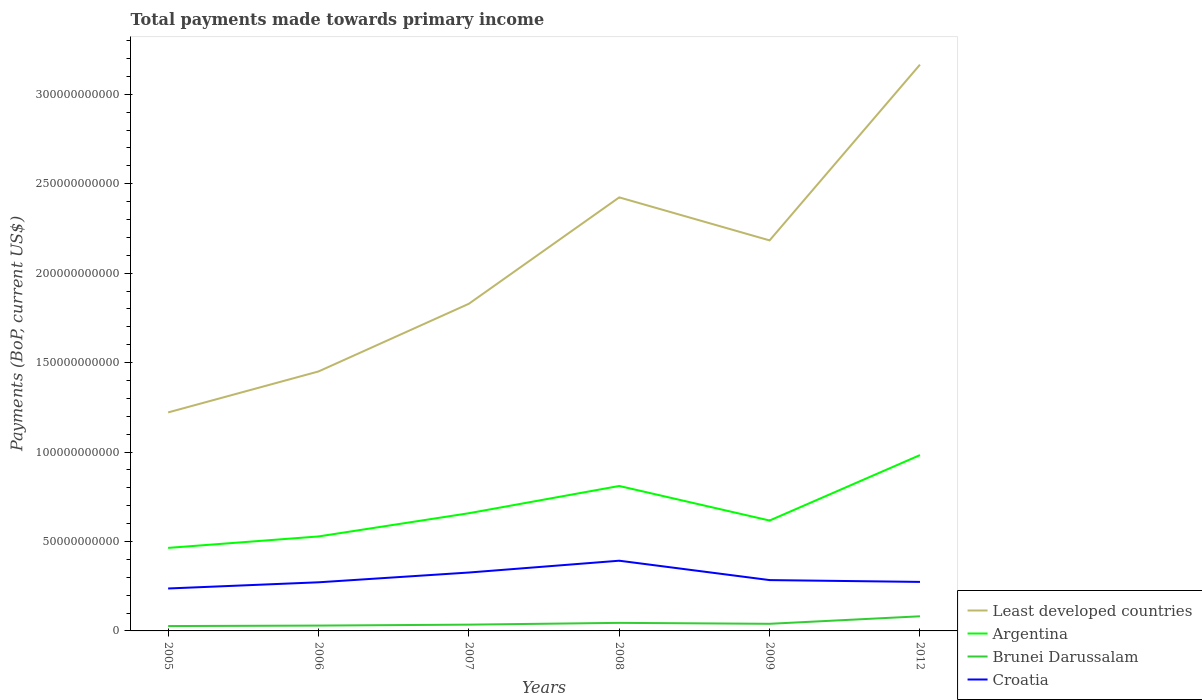Does the line corresponding to Brunei Darussalam intersect with the line corresponding to Argentina?
Your answer should be compact. No. Is the number of lines equal to the number of legend labels?
Offer a terse response. Yes. Across all years, what is the maximum total payments made towards primary income in Brunei Darussalam?
Your response must be concise. 2.71e+09. In which year was the total payments made towards primary income in Argentina maximum?
Give a very brief answer. 2005. What is the total total payments made towards primary income in Least developed countries in the graph?
Your response must be concise. -6.07e+1. What is the difference between the highest and the second highest total payments made towards primary income in Least developed countries?
Give a very brief answer. 1.94e+11. Is the total payments made towards primary income in Argentina strictly greater than the total payments made towards primary income in Croatia over the years?
Your answer should be compact. No. How many years are there in the graph?
Your response must be concise. 6. What is the difference between two consecutive major ticks on the Y-axis?
Keep it short and to the point. 5.00e+1. Are the values on the major ticks of Y-axis written in scientific E-notation?
Your answer should be very brief. No. How are the legend labels stacked?
Your answer should be very brief. Vertical. What is the title of the graph?
Give a very brief answer. Total payments made towards primary income. Does "Kenya" appear as one of the legend labels in the graph?
Provide a short and direct response. No. What is the label or title of the X-axis?
Make the answer very short. Years. What is the label or title of the Y-axis?
Offer a very short reply. Payments (BoP, current US$). What is the Payments (BoP, current US$) of Least developed countries in 2005?
Offer a terse response. 1.22e+11. What is the Payments (BoP, current US$) in Argentina in 2005?
Offer a very short reply. 4.64e+1. What is the Payments (BoP, current US$) of Brunei Darussalam in 2005?
Your answer should be compact. 2.71e+09. What is the Payments (BoP, current US$) of Croatia in 2005?
Provide a succinct answer. 2.37e+1. What is the Payments (BoP, current US$) of Least developed countries in 2006?
Offer a very short reply. 1.45e+11. What is the Payments (BoP, current US$) of Argentina in 2006?
Ensure brevity in your answer.  5.28e+1. What is the Payments (BoP, current US$) of Brunei Darussalam in 2006?
Give a very brief answer. 2.98e+09. What is the Payments (BoP, current US$) in Croatia in 2006?
Give a very brief answer. 2.72e+1. What is the Payments (BoP, current US$) in Least developed countries in 2007?
Ensure brevity in your answer.  1.83e+11. What is the Payments (BoP, current US$) of Argentina in 2007?
Your response must be concise. 6.58e+1. What is the Payments (BoP, current US$) of Brunei Darussalam in 2007?
Your answer should be compact. 3.51e+09. What is the Payments (BoP, current US$) of Croatia in 2007?
Make the answer very short. 3.26e+1. What is the Payments (BoP, current US$) of Least developed countries in 2008?
Provide a succinct answer. 2.42e+11. What is the Payments (BoP, current US$) of Argentina in 2008?
Provide a succinct answer. 8.10e+1. What is the Payments (BoP, current US$) of Brunei Darussalam in 2008?
Give a very brief answer. 4.51e+09. What is the Payments (BoP, current US$) of Croatia in 2008?
Give a very brief answer. 3.92e+1. What is the Payments (BoP, current US$) of Least developed countries in 2009?
Offer a terse response. 2.18e+11. What is the Payments (BoP, current US$) in Argentina in 2009?
Provide a short and direct response. 6.17e+1. What is the Payments (BoP, current US$) in Brunei Darussalam in 2009?
Offer a very short reply. 3.98e+09. What is the Payments (BoP, current US$) of Croatia in 2009?
Offer a very short reply. 2.84e+1. What is the Payments (BoP, current US$) of Least developed countries in 2012?
Your answer should be very brief. 3.17e+11. What is the Payments (BoP, current US$) in Argentina in 2012?
Keep it short and to the point. 9.83e+1. What is the Payments (BoP, current US$) in Brunei Darussalam in 2012?
Offer a very short reply. 8.18e+09. What is the Payments (BoP, current US$) in Croatia in 2012?
Make the answer very short. 2.74e+1. Across all years, what is the maximum Payments (BoP, current US$) of Least developed countries?
Offer a terse response. 3.17e+11. Across all years, what is the maximum Payments (BoP, current US$) in Argentina?
Offer a very short reply. 9.83e+1. Across all years, what is the maximum Payments (BoP, current US$) of Brunei Darussalam?
Offer a terse response. 8.18e+09. Across all years, what is the maximum Payments (BoP, current US$) of Croatia?
Your answer should be compact. 3.92e+1. Across all years, what is the minimum Payments (BoP, current US$) in Least developed countries?
Provide a short and direct response. 1.22e+11. Across all years, what is the minimum Payments (BoP, current US$) of Argentina?
Give a very brief answer. 4.64e+1. Across all years, what is the minimum Payments (BoP, current US$) of Brunei Darussalam?
Keep it short and to the point. 2.71e+09. Across all years, what is the minimum Payments (BoP, current US$) in Croatia?
Offer a terse response. 2.37e+1. What is the total Payments (BoP, current US$) of Least developed countries in the graph?
Give a very brief answer. 1.23e+12. What is the total Payments (BoP, current US$) in Argentina in the graph?
Ensure brevity in your answer.  4.06e+11. What is the total Payments (BoP, current US$) in Brunei Darussalam in the graph?
Your answer should be compact. 2.59e+1. What is the total Payments (BoP, current US$) in Croatia in the graph?
Keep it short and to the point. 1.79e+11. What is the difference between the Payments (BoP, current US$) of Least developed countries in 2005 and that in 2006?
Keep it short and to the point. -2.29e+1. What is the difference between the Payments (BoP, current US$) of Argentina in 2005 and that in 2006?
Provide a succinct answer. -6.39e+09. What is the difference between the Payments (BoP, current US$) in Brunei Darussalam in 2005 and that in 2006?
Offer a terse response. -2.72e+08. What is the difference between the Payments (BoP, current US$) in Croatia in 2005 and that in 2006?
Ensure brevity in your answer.  -3.46e+09. What is the difference between the Payments (BoP, current US$) of Least developed countries in 2005 and that in 2007?
Your response must be concise. -6.07e+1. What is the difference between the Payments (BoP, current US$) in Argentina in 2005 and that in 2007?
Your answer should be compact. -1.94e+1. What is the difference between the Payments (BoP, current US$) of Brunei Darussalam in 2005 and that in 2007?
Give a very brief answer. -8.03e+08. What is the difference between the Payments (BoP, current US$) in Croatia in 2005 and that in 2007?
Give a very brief answer. -8.92e+09. What is the difference between the Payments (BoP, current US$) of Least developed countries in 2005 and that in 2008?
Give a very brief answer. -1.20e+11. What is the difference between the Payments (BoP, current US$) in Argentina in 2005 and that in 2008?
Your answer should be very brief. -3.46e+1. What is the difference between the Payments (BoP, current US$) in Brunei Darussalam in 2005 and that in 2008?
Keep it short and to the point. -1.80e+09. What is the difference between the Payments (BoP, current US$) of Croatia in 2005 and that in 2008?
Your response must be concise. -1.55e+1. What is the difference between the Payments (BoP, current US$) in Least developed countries in 2005 and that in 2009?
Provide a succinct answer. -9.62e+1. What is the difference between the Payments (BoP, current US$) in Argentina in 2005 and that in 2009?
Offer a terse response. -1.53e+1. What is the difference between the Payments (BoP, current US$) of Brunei Darussalam in 2005 and that in 2009?
Ensure brevity in your answer.  -1.27e+09. What is the difference between the Payments (BoP, current US$) of Croatia in 2005 and that in 2009?
Your answer should be very brief. -4.69e+09. What is the difference between the Payments (BoP, current US$) in Least developed countries in 2005 and that in 2012?
Your answer should be compact. -1.94e+11. What is the difference between the Payments (BoP, current US$) of Argentina in 2005 and that in 2012?
Provide a succinct answer. -5.19e+1. What is the difference between the Payments (BoP, current US$) of Brunei Darussalam in 2005 and that in 2012?
Your answer should be compact. -5.47e+09. What is the difference between the Payments (BoP, current US$) of Croatia in 2005 and that in 2012?
Ensure brevity in your answer.  -3.68e+09. What is the difference between the Payments (BoP, current US$) in Least developed countries in 2006 and that in 2007?
Give a very brief answer. -3.78e+1. What is the difference between the Payments (BoP, current US$) in Argentina in 2006 and that in 2007?
Offer a very short reply. -1.30e+1. What is the difference between the Payments (BoP, current US$) in Brunei Darussalam in 2006 and that in 2007?
Offer a very short reply. -5.30e+08. What is the difference between the Payments (BoP, current US$) in Croatia in 2006 and that in 2007?
Ensure brevity in your answer.  -5.47e+09. What is the difference between the Payments (BoP, current US$) of Least developed countries in 2006 and that in 2008?
Your answer should be very brief. -9.73e+1. What is the difference between the Payments (BoP, current US$) in Argentina in 2006 and that in 2008?
Give a very brief answer. -2.82e+1. What is the difference between the Payments (BoP, current US$) of Brunei Darussalam in 2006 and that in 2008?
Offer a very short reply. -1.52e+09. What is the difference between the Payments (BoP, current US$) of Croatia in 2006 and that in 2008?
Keep it short and to the point. -1.21e+1. What is the difference between the Payments (BoP, current US$) in Least developed countries in 2006 and that in 2009?
Offer a very short reply. -7.33e+1. What is the difference between the Payments (BoP, current US$) of Argentina in 2006 and that in 2009?
Keep it short and to the point. -8.90e+09. What is the difference between the Payments (BoP, current US$) of Brunei Darussalam in 2006 and that in 2009?
Your answer should be compact. -9.96e+08. What is the difference between the Payments (BoP, current US$) of Croatia in 2006 and that in 2009?
Provide a short and direct response. -1.24e+09. What is the difference between the Payments (BoP, current US$) of Least developed countries in 2006 and that in 2012?
Your answer should be very brief. -1.72e+11. What is the difference between the Payments (BoP, current US$) in Argentina in 2006 and that in 2012?
Give a very brief answer. -4.55e+1. What is the difference between the Payments (BoP, current US$) of Brunei Darussalam in 2006 and that in 2012?
Give a very brief answer. -5.20e+09. What is the difference between the Payments (BoP, current US$) of Croatia in 2006 and that in 2012?
Your answer should be very brief. -2.25e+08. What is the difference between the Payments (BoP, current US$) of Least developed countries in 2007 and that in 2008?
Your answer should be compact. -5.95e+1. What is the difference between the Payments (BoP, current US$) of Argentina in 2007 and that in 2008?
Make the answer very short. -1.52e+1. What is the difference between the Payments (BoP, current US$) of Brunei Darussalam in 2007 and that in 2008?
Give a very brief answer. -9.95e+08. What is the difference between the Payments (BoP, current US$) in Croatia in 2007 and that in 2008?
Offer a terse response. -6.60e+09. What is the difference between the Payments (BoP, current US$) of Least developed countries in 2007 and that in 2009?
Offer a very short reply. -3.54e+1. What is the difference between the Payments (BoP, current US$) in Argentina in 2007 and that in 2009?
Ensure brevity in your answer.  4.09e+09. What is the difference between the Payments (BoP, current US$) of Brunei Darussalam in 2007 and that in 2009?
Your answer should be very brief. -4.66e+08. What is the difference between the Payments (BoP, current US$) in Croatia in 2007 and that in 2009?
Your response must be concise. 4.23e+09. What is the difference between the Payments (BoP, current US$) in Least developed countries in 2007 and that in 2012?
Offer a terse response. -1.34e+11. What is the difference between the Payments (BoP, current US$) of Argentina in 2007 and that in 2012?
Make the answer very short. -3.25e+1. What is the difference between the Payments (BoP, current US$) in Brunei Darussalam in 2007 and that in 2012?
Keep it short and to the point. -4.67e+09. What is the difference between the Payments (BoP, current US$) of Croatia in 2007 and that in 2012?
Your answer should be compact. 5.24e+09. What is the difference between the Payments (BoP, current US$) in Least developed countries in 2008 and that in 2009?
Provide a succinct answer. 2.40e+1. What is the difference between the Payments (BoP, current US$) of Argentina in 2008 and that in 2009?
Your answer should be compact. 1.93e+1. What is the difference between the Payments (BoP, current US$) of Brunei Darussalam in 2008 and that in 2009?
Keep it short and to the point. 5.28e+08. What is the difference between the Payments (BoP, current US$) of Croatia in 2008 and that in 2009?
Give a very brief answer. 1.08e+1. What is the difference between the Payments (BoP, current US$) of Least developed countries in 2008 and that in 2012?
Ensure brevity in your answer.  -7.42e+1. What is the difference between the Payments (BoP, current US$) of Argentina in 2008 and that in 2012?
Your response must be concise. -1.73e+1. What is the difference between the Payments (BoP, current US$) of Brunei Darussalam in 2008 and that in 2012?
Provide a succinct answer. -3.67e+09. What is the difference between the Payments (BoP, current US$) of Croatia in 2008 and that in 2012?
Your response must be concise. 1.18e+1. What is the difference between the Payments (BoP, current US$) of Least developed countries in 2009 and that in 2012?
Offer a terse response. -9.82e+1. What is the difference between the Payments (BoP, current US$) in Argentina in 2009 and that in 2012?
Offer a very short reply. -3.66e+1. What is the difference between the Payments (BoP, current US$) in Brunei Darussalam in 2009 and that in 2012?
Provide a succinct answer. -4.20e+09. What is the difference between the Payments (BoP, current US$) of Croatia in 2009 and that in 2012?
Provide a succinct answer. 1.01e+09. What is the difference between the Payments (BoP, current US$) in Least developed countries in 2005 and the Payments (BoP, current US$) in Argentina in 2006?
Offer a very short reply. 6.93e+1. What is the difference between the Payments (BoP, current US$) in Least developed countries in 2005 and the Payments (BoP, current US$) in Brunei Darussalam in 2006?
Offer a terse response. 1.19e+11. What is the difference between the Payments (BoP, current US$) in Least developed countries in 2005 and the Payments (BoP, current US$) in Croatia in 2006?
Give a very brief answer. 9.50e+1. What is the difference between the Payments (BoP, current US$) in Argentina in 2005 and the Payments (BoP, current US$) in Brunei Darussalam in 2006?
Your answer should be very brief. 4.34e+1. What is the difference between the Payments (BoP, current US$) of Argentina in 2005 and the Payments (BoP, current US$) of Croatia in 2006?
Ensure brevity in your answer.  1.92e+1. What is the difference between the Payments (BoP, current US$) of Brunei Darussalam in 2005 and the Payments (BoP, current US$) of Croatia in 2006?
Your answer should be compact. -2.45e+1. What is the difference between the Payments (BoP, current US$) in Least developed countries in 2005 and the Payments (BoP, current US$) in Argentina in 2007?
Make the answer very short. 5.63e+1. What is the difference between the Payments (BoP, current US$) in Least developed countries in 2005 and the Payments (BoP, current US$) in Brunei Darussalam in 2007?
Offer a terse response. 1.19e+11. What is the difference between the Payments (BoP, current US$) of Least developed countries in 2005 and the Payments (BoP, current US$) of Croatia in 2007?
Your response must be concise. 8.95e+1. What is the difference between the Payments (BoP, current US$) of Argentina in 2005 and the Payments (BoP, current US$) of Brunei Darussalam in 2007?
Your response must be concise. 4.29e+1. What is the difference between the Payments (BoP, current US$) in Argentina in 2005 and the Payments (BoP, current US$) in Croatia in 2007?
Ensure brevity in your answer.  1.38e+1. What is the difference between the Payments (BoP, current US$) in Brunei Darussalam in 2005 and the Payments (BoP, current US$) in Croatia in 2007?
Keep it short and to the point. -2.99e+1. What is the difference between the Payments (BoP, current US$) in Least developed countries in 2005 and the Payments (BoP, current US$) in Argentina in 2008?
Provide a short and direct response. 4.11e+1. What is the difference between the Payments (BoP, current US$) of Least developed countries in 2005 and the Payments (BoP, current US$) of Brunei Darussalam in 2008?
Make the answer very short. 1.18e+11. What is the difference between the Payments (BoP, current US$) of Least developed countries in 2005 and the Payments (BoP, current US$) of Croatia in 2008?
Your answer should be compact. 8.29e+1. What is the difference between the Payments (BoP, current US$) in Argentina in 2005 and the Payments (BoP, current US$) in Brunei Darussalam in 2008?
Provide a short and direct response. 4.19e+1. What is the difference between the Payments (BoP, current US$) in Argentina in 2005 and the Payments (BoP, current US$) in Croatia in 2008?
Provide a succinct answer. 7.17e+09. What is the difference between the Payments (BoP, current US$) in Brunei Darussalam in 2005 and the Payments (BoP, current US$) in Croatia in 2008?
Keep it short and to the point. -3.65e+1. What is the difference between the Payments (BoP, current US$) of Least developed countries in 2005 and the Payments (BoP, current US$) of Argentina in 2009?
Provide a succinct answer. 6.04e+1. What is the difference between the Payments (BoP, current US$) in Least developed countries in 2005 and the Payments (BoP, current US$) in Brunei Darussalam in 2009?
Offer a terse response. 1.18e+11. What is the difference between the Payments (BoP, current US$) in Least developed countries in 2005 and the Payments (BoP, current US$) in Croatia in 2009?
Your response must be concise. 9.37e+1. What is the difference between the Payments (BoP, current US$) in Argentina in 2005 and the Payments (BoP, current US$) in Brunei Darussalam in 2009?
Keep it short and to the point. 4.24e+1. What is the difference between the Payments (BoP, current US$) of Argentina in 2005 and the Payments (BoP, current US$) of Croatia in 2009?
Provide a succinct answer. 1.80e+1. What is the difference between the Payments (BoP, current US$) in Brunei Darussalam in 2005 and the Payments (BoP, current US$) in Croatia in 2009?
Your answer should be compact. -2.57e+1. What is the difference between the Payments (BoP, current US$) of Least developed countries in 2005 and the Payments (BoP, current US$) of Argentina in 2012?
Your response must be concise. 2.39e+1. What is the difference between the Payments (BoP, current US$) in Least developed countries in 2005 and the Payments (BoP, current US$) in Brunei Darussalam in 2012?
Your answer should be compact. 1.14e+11. What is the difference between the Payments (BoP, current US$) of Least developed countries in 2005 and the Payments (BoP, current US$) of Croatia in 2012?
Keep it short and to the point. 9.47e+1. What is the difference between the Payments (BoP, current US$) of Argentina in 2005 and the Payments (BoP, current US$) of Brunei Darussalam in 2012?
Offer a terse response. 3.82e+1. What is the difference between the Payments (BoP, current US$) of Argentina in 2005 and the Payments (BoP, current US$) of Croatia in 2012?
Give a very brief answer. 1.90e+1. What is the difference between the Payments (BoP, current US$) in Brunei Darussalam in 2005 and the Payments (BoP, current US$) in Croatia in 2012?
Make the answer very short. -2.47e+1. What is the difference between the Payments (BoP, current US$) in Least developed countries in 2006 and the Payments (BoP, current US$) in Argentina in 2007?
Provide a succinct answer. 7.92e+1. What is the difference between the Payments (BoP, current US$) in Least developed countries in 2006 and the Payments (BoP, current US$) in Brunei Darussalam in 2007?
Keep it short and to the point. 1.42e+11. What is the difference between the Payments (BoP, current US$) of Least developed countries in 2006 and the Payments (BoP, current US$) of Croatia in 2007?
Your answer should be compact. 1.12e+11. What is the difference between the Payments (BoP, current US$) in Argentina in 2006 and the Payments (BoP, current US$) in Brunei Darussalam in 2007?
Provide a succinct answer. 4.93e+1. What is the difference between the Payments (BoP, current US$) of Argentina in 2006 and the Payments (BoP, current US$) of Croatia in 2007?
Offer a very short reply. 2.02e+1. What is the difference between the Payments (BoP, current US$) in Brunei Darussalam in 2006 and the Payments (BoP, current US$) in Croatia in 2007?
Make the answer very short. -2.97e+1. What is the difference between the Payments (BoP, current US$) in Least developed countries in 2006 and the Payments (BoP, current US$) in Argentina in 2008?
Provide a short and direct response. 6.40e+1. What is the difference between the Payments (BoP, current US$) in Least developed countries in 2006 and the Payments (BoP, current US$) in Brunei Darussalam in 2008?
Keep it short and to the point. 1.41e+11. What is the difference between the Payments (BoP, current US$) of Least developed countries in 2006 and the Payments (BoP, current US$) of Croatia in 2008?
Offer a terse response. 1.06e+11. What is the difference between the Payments (BoP, current US$) of Argentina in 2006 and the Payments (BoP, current US$) of Brunei Darussalam in 2008?
Make the answer very short. 4.83e+1. What is the difference between the Payments (BoP, current US$) of Argentina in 2006 and the Payments (BoP, current US$) of Croatia in 2008?
Ensure brevity in your answer.  1.36e+1. What is the difference between the Payments (BoP, current US$) in Brunei Darussalam in 2006 and the Payments (BoP, current US$) in Croatia in 2008?
Give a very brief answer. -3.63e+1. What is the difference between the Payments (BoP, current US$) in Least developed countries in 2006 and the Payments (BoP, current US$) in Argentina in 2009?
Provide a succinct answer. 8.33e+1. What is the difference between the Payments (BoP, current US$) of Least developed countries in 2006 and the Payments (BoP, current US$) of Brunei Darussalam in 2009?
Offer a very short reply. 1.41e+11. What is the difference between the Payments (BoP, current US$) of Least developed countries in 2006 and the Payments (BoP, current US$) of Croatia in 2009?
Make the answer very short. 1.17e+11. What is the difference between the Payments (BoP, current US$) in Argentina in 2006 and the Payments (BoP, current US$) in Brunei Darussalam in 2009?
Your response must be concise. 4.88e+1. What is the difference between the Payments (BoP, current US$) in Argentina in 2006 and the Payments (BoP, current US$) in Croatia in 2009?
Your answer should be compact. 2.44e+1. What is the difference between the Payments (BoP, current US$) in Brunei Darussalam in 2006 and the Payments (BoP, current US$) in Croatia in 2009?
Provide a short and direct response. -2.54e+1. What is the difference between the Payments (BoP, current US$) in Least developed countries in 2006 and the Payments (BoP, current US$) in Argentina in 2012?
Your answer should be compact. 4.68e+1. What is the difference between the Payments (BoP, current US$) in Least developed countries in 2006 and the Payments (BoP, current US$) in Brunei Darussalam in 2012?
Offer a terse response. 1.37e+11. What is the difference between the Payments (BoP, current US$) of Least developed countries in 2006 and the Payments (BoP, current US$) of Croatia in 2012?
Provide a succinct answer. 1.18e+11. What is the difference between the Payments (BoP, current US$) in Argentina in 2006 and the Payments (BoP, current US$) in Brunei Darussalam in 2012?
Offer a terse response. 4.46e+1. What is the difference between the Payments (BoP, current US$) in Argentina in 2006 and the Payments (BoP, current US$) in Croatia in 2012?
Give a very brief answer. 2.54e+1. What is the difference between the Payments (BoP, current US$) in Brunei Darussalam in 2006 and the Payments (BoP, current US$) in Croatia in 2012?
Keep it short and to the point. -2.44e+1. What is the difference between the Payments (BoP, current US$) of Least developed countries in 2007 and the Payments (BoP, current US$) of Argentina in 2008?
Offer a terse response. 1.02e+11. What is the difference between the Payments (BoP, current US$) in Least developed countries in 2007 and the Payments (BoP, current US$) in Brunei Darussalam in 2008?
Give a very brief answer. 1.78e+11. What is the difference between the Payments (BoP, current US$) of Least developed countries in 2007 and the Payments (BoP, current US$) of Croatia in 2008?
Make the answer very short. 1.44e+11. What is the difference between the Payments (BoP, current US$) in Argentina in 2007 and the Payments (BoP, current US$) in Brunei Darussalam in 2008?
Ensure brevity in your answer.  6.13e+1. What is the difference between the Payments (BoP, current US$) in Argentina in 2007 and the Payments (BoP, current US$) in Croatia in 2008?
Offer a very short reply. 2.65e+1. What is the difference between the Payments (BoP, current US$) in Brunei Darussalam in 2007 and the Payments (BoP, current US$) in Croatia in 2008?
Provide a short and direct response. -3.57e+1. What is the difference between the Payments (BoP, current US$) in Least developed countries in 2007 and the Payments (BoP, current US$) in Argentina in 2009?
Provide a short and direct response. 1.21e+11. What is the difference between the Payments (BoP, current US$) in Least developed countries in 2007 and the Payments (BoP, current US$) in Brunei Darussalam in 2009?
Your answer should be compact. 1.79e+11. What is the difference between the Payments (BoP, current US$) in Least developed countries in 2007 and the Payments (BoP, current US$) in Croatia in 2009?
Give a very brief answer. 1.54e+11. What is the difference between the Payments (BoP, current US$) of Argentina in 2007 and the Payments (BoP, current US$) of Brunei Darussalam in 2009?
Provide a short and direct response. 6.18e+1. What is the difference between the Payments (BoP, current US$) of Argentina in 2007 and the Payments (BoP, current US$) of Croatia in 2009?
Offer a very short reply. 3.74e+1. What is the difference between the Payments (BoP, current US$) of Brunei Darussalam in 2007 and the Payments (BoP, current US$) of Croatia in 2009?
Give a very brief answer. -2.49e+1. What is the difference between the Payments (BoP, current US$) in Least developed countries in 2007 and the Payments (BoP, current US$) in Argentina in 2012?
Give a very brief answer. 8.46e+1. What is the difference between the Payments (BoP, current US$) in Least developed countries in 2007 and the Payments (BoP, current US$) in Brunei Darussalam in 2012?
Your answer should be compact. 1.75e+11. What is the difference between the Payments (BoP, current US$) of Least developed countries in 2007 and the Payments (BoP, current US$) of Croatia in 2012?
Ensure brevity in your answer.  1.55e+11. What is the difference between the Payments (BoP, current US$) of Argentina in 2007 and the Payments (BoP, current US$) of Brunei Darussalam in 2012?
Provide a succinct answer. 5.76e+1. What is the difference between the Payments (BoP, current US$) in Argentina in 2007 and the Payments (BoP, current US$) in Croatia in 2012?
Give a very brief answer. 3.84e+1. What is the difference between the Payments (BoP, current US$) in Brunei Darussalam in 2007 and the Payments (BoP, current US$) in Croatia in 2012?
Your answer should be compact. -2.39e+1. What is the difference between the Payments (BoP, current US$) of Least developed countries in 2008 and the Payments (BoP, current US$) of Argentina in 2009?
Ensure brevity in your answer.  1.81e+11. What is the difference between the Payments (BoP, current US$) in Least developed countries in 2008 and the Payments (BoP, current US$) in Brunei Darussalam in 2009?
Keep it short and to the point. 2.38e+11. What is the difference between the Payments (BoP, current US$) in Least developed countries in 2008 and the Payments (BoP, current US$) in Croatia in 2009?
Offer a terse response. 2.14e+11. What is the difference between the Payments (BoP, current US$) in Argentina in 2008 and the Payments (BoP, current US$) in Brunei Darussalam in 2009?
Keep it short and to the point. 7.70e+1. What is the difference between the Payments (BoP, current US$) in Argentina in 2008 and the Payments (BoP, current US$) in Croatia in 2009?
Ensure brevity in your answer.  5.26e+1. What is the difference between the Payments (BoP, current US$) in Brunei Darussalam in 2008 and the Payments (BoP, current US$) in Croatia in 2009?
Make the answer very short. -2.39e+1. What is the difference between the Payments (BoP, current US$) in Least developed countries in 2008 and the Payments (BoP, current US$) in Argentina in 2012?
Provide a short and direct response. 1.44e+11. What is the difference between the Payments (BoP, current US$) in Least developed countries in 2008 and the Payments (BoP, current US$) in Brunei Darussalam in 2012?
Your answer should be compact. 2.34e+11. What is the difference between the Payments (BoP, current US$) in Least developed countries in 2008 and the Payments (BoP, current US$) in Croatia in 2012?
Your response must be concise. 2.15e+11. What is the difference between the Payments (BoP, current US$) of Argentina in 2008 and the Payments (BoP, current US$) of Brunei Darussalam in 2012?
Your answer should be very brief. 7.28e+1. What is the difference between the Payments (BoP, current US$) of Argentina in 2008 and the Payments (BoP, current US$) of Croatia in 2012?
Keep it short and to the point. 5.36e+1. What is the difference between the Payments (BoP, current US$) of Brunei Darussalam in 2008 and the Payments (BoP, current US$) of Croatia in 2012?
Keep it short and to the point. -2.29e+1. What is the difference between the Payments (BoP, current US$) in Least developed countries in 2009 and the Payments (BoP, current US$) in Argentina in 2012?
Provide a succinct answer. 1.20e+11. What is the difference between the Payments (BoP, current US$) in Least developed countries in 2009 and the Payments (BoP, current US$) in Brunei Darussalam in 2012?
Ensure brevity in your answer.  2.10e+11. What is the difference between the Payments (BoP, current US$) in Least developed countries in 2009 and the Payments (BoP, current US$) in Croatia in 2012?
Make the answer very short. 1.91e+11. What is the difference between the Payments (BoP, current US$) of Argentina in 2009 and the Payments (BoP, current US$) of Brunei Darussalam in 2012?
Offer a very short reply. 5.35e+1. What is the difference between the Payments (BoP, current US$) in Argentina in 2009 and the Payments (BoP, current US$) in Croatia in 2012?
Your answer should be very brief. 3.43e+1. What is the difference between the Payments (BoP, current US$) in Brunei Darussalam in 2009 and the Payments (BoP, current US$) in Croatia in 2012?
Provide a succinct answer. -2.34e+1. What is the average Payments (BoP, current US$) of Least developed countries per year?
Give a very brief answer. 2.05e+11. What is the average Payments (BoP, current US$) in Argentina per year?
Offer a terse response. 6.77e+1. What is the average Payments (BoP, current US$) of Brunei Darussalam per year?
Offer a terse response. 4.31e+09. What is the average Payments (BoP, current US$) of Croatia per year?
Ensure brevity in your answer.  2.98e+1. In the year 2005, what is the difference between the Payments (BoP, current US$) of Least developed countries and Payments (BoP, current US$) of Argentina?
Provide a succinct answer. 7.57e+1. In the year 2005, what is the difference between the Payments (BoP, current US$) of Least developed countries and Payments (BoP, current US$) of Brunei Darussalam?
Keep it short and to the point. 1.19e+11. In the year 2005, what is the difference between the Payments (BoP, current US$) in Least developed countries and Payments (BoP, current US$) in Croatia?
Your answer should be very brief. 9.84e+1. In the year 2005, what is the difference between the Payments (BoP, current US$) in Argentina and Payments (BoP, current US$) in Brunei Darussalam?
Your answer should be very brief. 4.37e+1. In the year 2005, what is the difference between the Payments (BoP, current US$) in Argentina and Payments (BoP, current US$) in Croatia?
Give a very brief answer. 2.27e+1. In the year 2005, what is the difference between the Payments (BoP, current US$) of Brunei Darussalam and Payments (BoP, current US$) of Croatia?
Provide a succinct answer. -2.10e+1. In the year 2006, what is the difference between the Payments (BoP, current US$) of Least developed countries and Payments (BoP, current US$) of Argentina?
Offer a very short reply. 9.22e+1. In the year 2006, what is the difference between the Payments (BoP, current US$) in Least developed countries and Payments (BoP, current US$) in Brunei Darussalam?
Give a very brief answer. 1.42e+11. In the year 2006, what is the difference between the Payments (BoP, current US$) in Least developed countries and Payments (BoP, current US$) in Croatia?
Provide a short and direct response. 1.18e+11. In the year 2006, what is the difference between the Payments (BoP, current US$) of Argentina and Payments (BoP, current US$) of Brunei Darussalam?
Your answer should be very brief. 4.98e+1. In the year 2006, what is the difference between the Payments (BoP, current US$) in Argentina and Payments (BoP, current US$) in Croatia?
Give a very brief answer. 2.56e+1. In the year 2006, what is the difference between the Payments (BoP, current US$) of Brunei Darussalam and Payments (BoP, current US$) of Croatia?
Provide a short and direct response. -2.42e+1. In the year 2007, what is the difference between the Payments (BoP, current US$) of Least developed countries and Payments (BoP, current US$) of Argentina?
Provide a short and direct response. 1.17e+11. In the year 2007, what is the difference between the Payments (BoP, current US$) in Least developed countries and Payments (BoP, current US$) in Brunei Darussalam?
Provide a short and direct response. 1.79e+11. In the year 2007, what is the difference between the Payments (BoP, current US$) of Least developed countries and Payments (BoP, current US$) of Croatia?
Make the answer very short. 1.50e+11. In the year 2007, what is the difference between the Payments (BoP, current US$) in Argentina and Payments (BoP, current US$) in Brunei Darussalam?
Your answer should be very brief. 6.23e+1. In the year 2007, what is the difference between the Payments (BoP, current US$) in Argentina and Payments (BoP, current US$) in Croatia?
Ensure brevity in your answer.  3.31e+1. In the year 2007, what is the difference between the Payments (BoP, current US$) of Brunei Darussalam and Payments (BoP, current US$) of Croatia?
Keep it short and to the point. -2.91e+1. In the year 2008, what is the difference between the Payments (BoP, current US$) of Least developed countries and Payments (BoP, current US$) of Argentina?
Offer a terse response. 1.61e+11. In the year 2008, what is the difference between the Payments (BoP, current US$) of Least developed countries and Payments (BoP, current US$) of Brunei Darussalam?
Your answer should be very brief. 2.38e+11. In the year 2008, what is the difference between the Payments (BoP, current US$) in Least developed countries and Payments (BoP, current US$) in Croatia?
Provide a succinct answer. 2.03e+11. In the year 2008, what is the difference between the Payments (BoP, current US$) of Argentina and Payments (BoP, current US$) of Brunei Darussalam?
Your answer should be compact. 7.65e+1. In the year 2008, what is the difference between the Payments (BoP, current US$) of Argentina and Payments (BoP, current US$) of Croatia?
Your answer should be compact. 4.18e+1. In the year 2008, what is the difference between the Payments (BoP, current US$) of Brunei Darussalam and Payments (BoP, current US$) of Croatia?
Ensure brevity in your answer.  -3.47e+1. In the year 2009, what is the difference between the Payments (BoP, current US$) of Least developed countries and Payments (BoP, current US$) of Argentina?
Offer a terse response. 1.57e+11. In the year 2009, what is the difference between the Payments (BoP, current US$) in Least developed countries and Payments (BoP, current US$) in Brunei Darussalam?
Offer a terse response. 2.14e+11. In the year 2009, what is the difference between the Payments (BoP, current US$) in Least developed countries and Payments (BoP, current US$) in Croatia?
Your answer should be very brief. 1.90e+11. In the year 2009, what is the difference between the Payments (BoP, current US$) of Argentina and Payments (BoP, current US$) of Brunei Darussalam?
Ensure brevity in your answer.  5.77e+1. In the year 2009, what is the difference between the Payments (BoP, current US$) in Argentina and Payments (BoP, current US$) in Croatia?
Offer a very short reply. 3.33e+1. In the year 2009, what is the difference between the Payments (BoP, current US$) in Brunei Darussalam and Payments (BoP, current US$) in Croatia?
Keep it short and to the point. -2.44e+1. In the year 2012, what is the difference between the Payments (BoP, current US$) of Least developed countries and Payments (BoP, current US$) of Argentina?
Offer a very short reply. 2.18e+11. In the year 2012, what is the difference between the Payments (BoP, current US$) of Least developed countries and Payments (BoP, current US$) of Brunei Darussalam?
Ensure brevity in your answer.  3.08e+11. In the year 2012, what is the difference between the Payments (BoP, current US$) in Least developed countries and Payments (BoP, current US$) in Croatia?
Ensure brevity in your answer.  2.89e+11. In the year 2012, what is the difference between the Payments (BoP, current US$) of Argentina and Payments (BoP, current US$) of Brunei Darussalam?
Ensure brevity in your answer.  9.01e+1. In the year 2012, what is the difference between the Payments (BoP, current US$) in Argentina and Payments (BoP, current US$) in Croatia?
Provide a short and direct response. 7.09e+1. In the year 2012, what is the difference between the Payments (BoP, current US$) of Brunei Darussalam and Payments (BoP, current US$) of Croatia?
Ensure brevity in your answer.  -1.92e+1. What is the ratio of the Payments (BoP, current US$) in Least developed countries in 2005 to that in 2006?
Provide a short and direct response. 0.84. What is the ratio of the Payments (BoP, current US$) of Argentina in 2005 to that in 2006?
Offer a terse response. 0.88. What is the ratio of the Payments (BoP, current US$) of Brunei Darussalam in 2005 to that in 2006?
Your answer should be very brief. 0.91. What is the ratio of the Payments (BoP, current US$) in Croatia in 2005 to that in 2006?
Provide a succinct answer. 0.87. What is the ratio of the Payments (BoP, current US$) in Least developed countries in 2005 to that in 2007?
Give a very brief answer. 0.67. What is the ratio of the Payments (BoP, current US$) of Argentina in 2005 to that in 2007?
Your answer should be very brief. 0.71. What is the ratio of the Payments (BoP, current US$) in Brunei Darussalam in 2005 to that in 2007?
Ensure brevity in your answer.  0.77. What is the ratio of the Payments (BoP, current US$) in Croatia in 2005 to that in 2007?
Your response must be concise. 0.73. What is the ratio of the Payments (BoP, current US$) of Least developed countries in 2005 to that in 2008?
Ensure brevity in your answer.  0.5. What is the ratio of the Payments (BoP, current US$) of Argentina in 2005 to that in 2008?
Keep it short and to the point. 0.57. What is the ratio of the Payments (BoP, current US$) of Brunei Darussalam in 2005 to that in 2008?
Offer a very short reply. 0.6. What is the ratio of the Payments (BoP, current US$) in Croatia in 2005 to that in 2008?
Your answer should be very brief. 0.6. What is the ratio of the Payments (BoP, current US$) in Least developed countries in 2005 to that in 2009?
Keep it short and to the point. 0.56. What is the ratio of the Payments (BoP, current US$) of Argentina in 2005 to that in 2009?
Your answer should be compact. 0.75. What is the ratio of the Payments (BoP, current US$) of Brunei Darussalam in 2005 to that in 2009?
Your answer should be very brief. 0.68. What is the ratio of the Payments (BoP, current US$) in Croatia in 2005 to that in 2009?
Your answer should be very brief. 0.83. What is the ratio of the Payments (BoP, current US$) in Least developed countries in 2005 to that in 2012?
Provide a short and direct response. 0.39. What is the ratio of the Payments (BoP, current US$) in Argentina in 2005 to that in 2012?
Provide a succinct answer. 0.47. What is the ratio of the Payments (BoP, current US$) in Brunei Darussalam in 2005 to that in 2012?
Offer a terse response. 0.33. What is the ratio of the Payments (BoP, current US$) of Croatia in 2005 to that in 2012?
Keep it short and to the point. 0.87. What is the ratio of the Payments (BoP, current US$) of Least developed countries in 2006 to that in 2007?
Ensure brevity in your answer.  0.79. What is the ratio of the Payments (BoP, current US$) of Argentina in 2006 to that in 2007?
Ensure brevity in your answer.  0.8. What is the ratio of the Payments (BoP, current US$) in Brunei Darussalam in 2006 to that in 2007?
Give a very brief answer. 0.85. What is the ratio of the Payments (BoP, current US$) of Croatia in 2006 to that in 2007?
Ensure brevity in your answer.  0.83. What is the ratio of the Payments (BoP, current US$) of Least developed countries in 2006 to that in 2008?
Give a very brief answer. 0.6. What is the ratio of the Payments (BoP, current US$) in Argentina in 2006 to that in 2008?
Ensure brevity in your answer.  0.65. What is the ratio of the Payments (BoP, current US$) of Brunei Darussalam in 2006 to that in 2008?
Keep it short and to the point. 0.66. What is the ratio of the Payments (BoP, current US$) in Croatia in 2006 to that in 2008?
Offer a very short reply. 0.69. What is the ratio of the Payments (BoP, current US$) of Least developed countries in 2006 to that in 2009?
Give a very brief answer. 0.66. What is the ratio of the Payments (BoP, current US$) in Argentina in 2006 to that in 2009?
Make the answer very short. 0.86. What is the ratio of the Payments (BoP, current US$) in Brunei Darussalam in 2006 to that in 2009?
Your answer should be compact. 0.75. What is the ratio of the Payments (BoP, current US$) in Croatia in 2006 to that in 2009?
Provide a succinct answer. 0.96. What is the ratio of the Payments (BoP, current US$) of Least developed countries in 2006 to that in 2012?
Your answer should be compact. 0.46. What is the ratio of the Payments (BoP, current US$) in Argentina in 2006 to that in 2012?
Ensure brevity in your answer.  0.54. What is the ratio of the Payments (BoP, current US$) of Brunei Darussalam in 2006 to that in 2012?
Offer a very short reply. 0.36. What is the ratio of the Payments (BoP, current US$) of Croatia in 2006 to that in 2012?
Provide a short and direct response. 0.99. What is the ratio of the Payments (BoP, current US$) of Least developed countries in 2007 to that in 2008?
Ensure brevity in your answer.  0.75. What is the ratio of the Payments (BoP, current US$) in Argentina in 2007 to that in 2008?
Give a very brief answer. 0.81. What is the ratio of the Payments (BoP, current US$) in Brunei Darussalam in 2007 to that in 2008?
Your answer should be very brief. 0.78. What is the ratio of the Payments (BoP, current US$) in Croatia in 2007 to that in 2008?
Your response must be concise. 0.83. What is the ratio of the Payments (BoP, current US$) of Least developed countries in 2007 to that in 2009?
Give a very brief answer. 0.84. What is the ratio of the Payments (BoP, current US$) in Argentina in 2007 to that in 2009?
Offer a very short reply. 1.07. What is the ratio of the Payments (BoP, current US$) of Brunei Darussalam in 2007 to that in 2009?
Offer a very short reply. 0.88. What is the ratio of the Payments (BoP, current US$) in Croatia in 2007 to that in 2009?
Provide a succinct answer. 1.15. What is the ratio of the Payments (BoP, current US$) of Least developed countries in 2007 to that in 2012?
Provide a short and direct response. 0.58. What is the ratio of the Payments (BoP, current US$) in Argentina in 2007 to that in 2012?
Give a very brief answer. 0.67. What is the ratio of the Payments (BoP, current US$) of Brunei Darussalam in 2007 to that in 2012?
Your answer should be compact. 0.43. What is the ratio of the Payments (BoP, current US$) in Croatia in 2007 to that in 2012?
Offer a very short reply. 1.19. What is the ratio of the Payments (BoP, current US$) of Least developed countries in 2008 to that in 2009?
Keep it short and to the point. 1.11. What is the ratio of the Payments (BoP, current US$) of Argentina in 2008 to that in 2009?
Offer a terse response. 1.31. What is the ratio of the Payments (BoP, current US$) in Brunei Darussalam in 2008 to that in 2009?
Make the answer very short. 1.13. What is the ratio of the Payments (BoP, current US$) of Croatia in 2008 to that in 2009?
Offer a terse response. 1.38. What is the ratio of the Payments (BoP, current US$) of Least developed countries in 2008 to that in 2012?
Make the answer very short. 0.77. What is the ratio of the Payments (BoP, current US$) of Argentina in 2008 to that in 2012?
Offer a terse response. 0.82. What is the ratio of the Payments (BoP, current US$) of Brunei Darussalam in 2008 to that in 2012?
Your answer should be very brief. 0.55. What is the ratio of the Payments (BoP, current US$) of Croatia in 2008 to that in 2012?
Provide a short and direct response. 1.43. What is the ratio of the Payments (BoP, current US$) of Least developed countries in 2009 to that in 2012?
Make the answer very short. 0.69. What is the ratio of the Payments (BoP, current US$) of Argentina in 2009 to that in 2012?
Your answer should be very brief. 0.63. What is the ratio of the Payments (BoP, current US$) in Brunei Darussalam in 2009 to that in 2012?
Your answer should be compact. 0.49. What is the ratio of the Payments (BoP, current US$) of Croatia in 2009 to that in 2012?
Your answer should be compact. 1.04. What is the difference between the highest and the second highest Payments (BoP, current US$) in Least developed countries?
Your answer should be very brief. 7.42e+1. What is the difference between the highest and the second highest Payments (BoP, current US$) of Argentina?
Provide a short and direct response. 1.73e+1. What is the difference between the highest and the second highest Payments (BoP, current US$) of Brunei Darussalam?
Offer a very short reply. 3.67e+09. What is the difference between the highest and the second highest Payments (BoP, current US$) in Croatia?
Give a very brief answer. 6.60e+09. What is the difference between the highest and the lowest Payments (BoP, current US$) in Least developed countries?
Keep it short and to the point. 1.94e+11. What is the difference between the highest and the lowest Payments (BoP, current US$) in Argentina?
Make the answer very short. 5.19e+1. What is the difference between the highest and the lowest Payments (BoP, current US$) in Brunei Darussalam?
Your response must be concise. 5.47e+09. What is the difference between the highest and the lowest Payments (BoP, current US$) of Croatia?
Offer a terse response. 1.55e+1. 